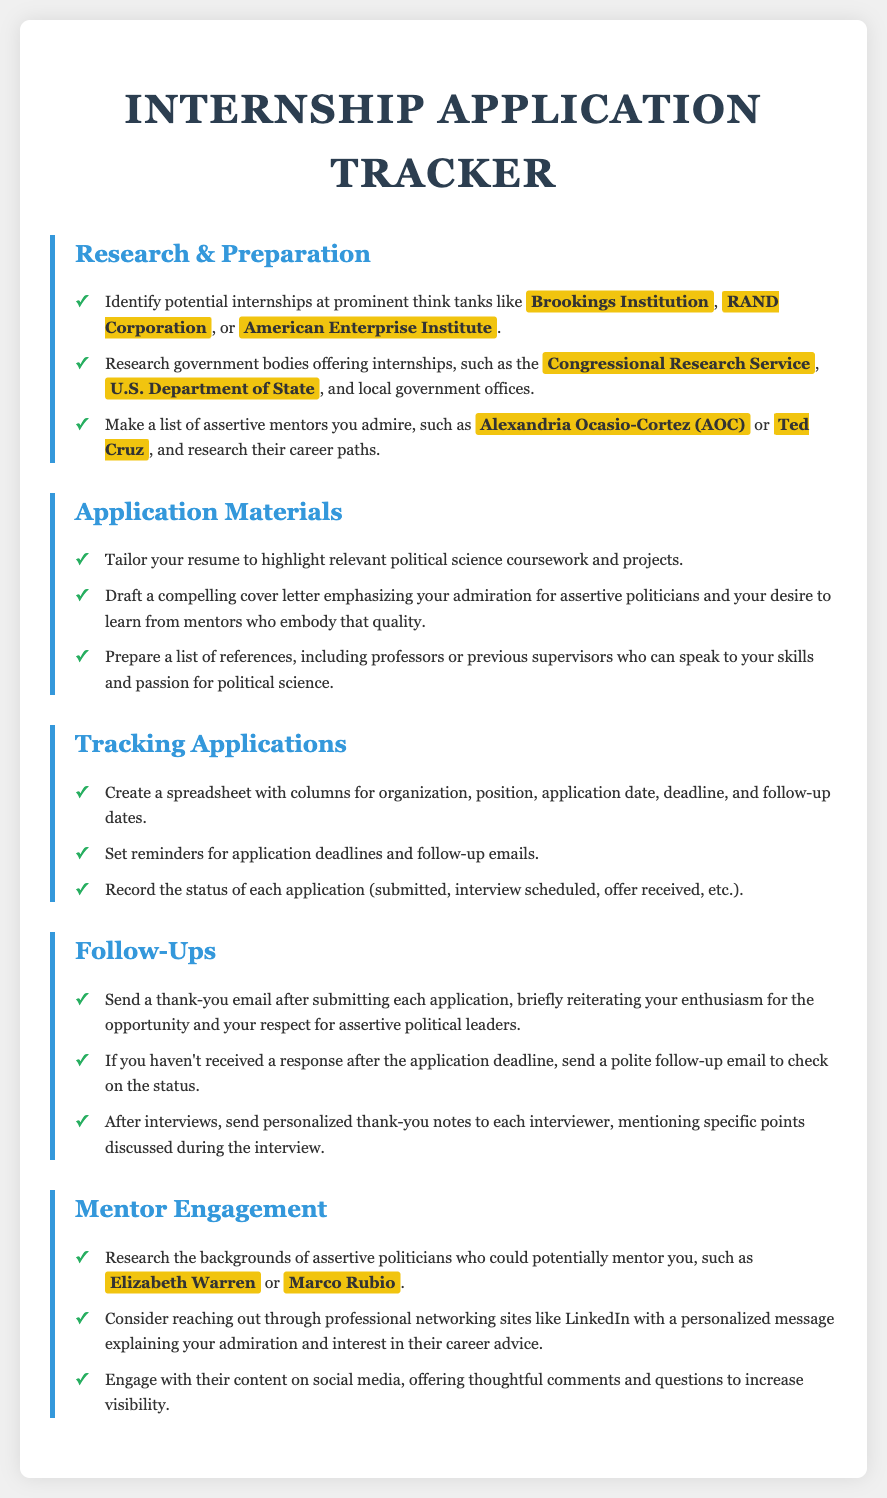what are three think tanks mentioned? The document lists three prominent think tanks where internships are sought, which are the Brookings Institution, RAND Corporation, and American Enterprise Institute.
Answer: Brookings Institution, RAND Corporation, American Enterprise Institute which government body is focused on international affairs? The document mentions the U.S. Department of State as a government body offering internships related to international affairs.
Answer: U.S. Department of State name two assertive politicians to admire. The document notes Alexandria Ocasio-Cortez and Ted Cruz as assertive politicians for whom one might seek mentorship.
Answer: Alexandria Ocasio-Cortez, Ted Cruz what is a suggested action after sending an application? The document advises sending a thank-you email after submitting an application to reiterate enthusiasm for the opportunity.
Answer: Thank-you email how should one prepare for applying to internships? The document recommends tailoring your resume to highlight relevant political science coursework and projects as part of the application preparation.
Answer: Tailor resume what should the tracking spreadsheet include? The document states that the tracking spreadsheet should have columns for organization, position, application date, deadline, and follow-up dates.
Answer: Organization, position, application date, deadline, follow-up dates which social media platform is suggested for networking? The document suggests using LinkedIn for reaching out to assertive politicians with personalized messages.
Answer: LinkedIn how to engage with assertive politicians' content? The document mentions engaging with their content on social media by offering thoughtful comments and questions.
Answer: Thoughtful comments and questions 